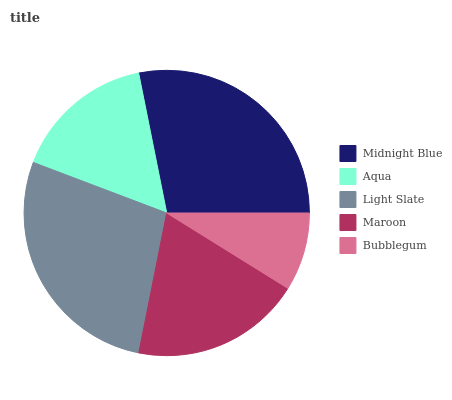Is Bubblegum the minimum?
Answer yes or no. Yes. Is Midnight Blue the maximum?
Answer yes or no. Yes. Is Aqua the minimum?
Answer yes or no. No. Is Aqua the maximum?
Answer yes or no. No. Is Midnight Blue greater than Aqua?
Answer yes or no. Yes. Is Aqua less than Midnight Blue?
Answer yes or no. Yes. Is Aqua greater than Midnight Blue?
Answer yes or no. No. Is Midnight Blue less than Aqua?
Answer yes or no. No. Is Maroon the high median?
Answer yes or no. Yes. Is Maroon the low median?
Answer yes or no. Yes. Is Midnight Blue the high median?
Answer yes or no. No. Is Light Slate the low median?
Answer yes or no. No. 